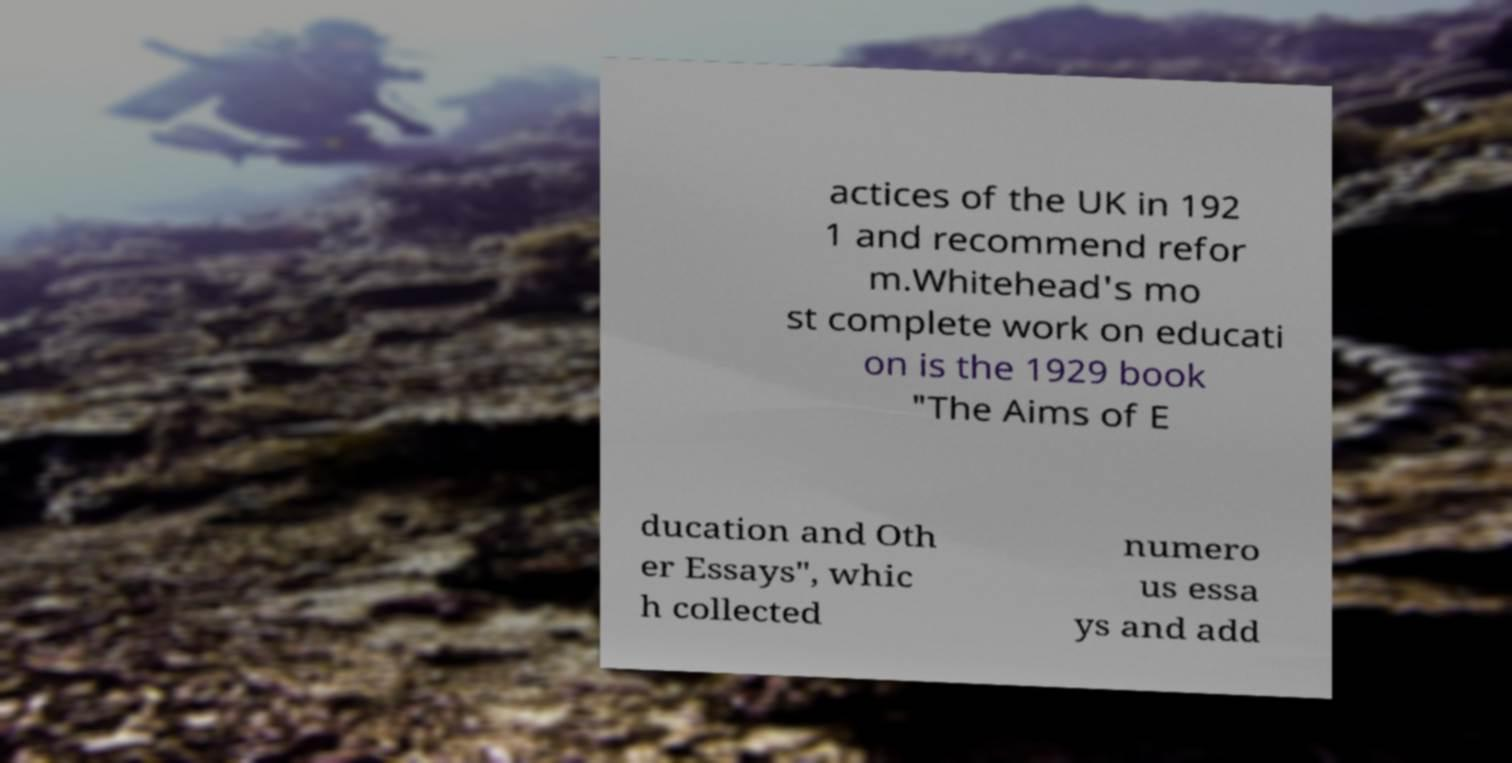Could you extract and type out the text from this image? actices of the UK in 192 1 and recommend refor m.Whitehead's mo st complete work on educati on is the 1929 book "The Aims of E ducation and Oth er Essays", whic h collected numero us essa ys and add 